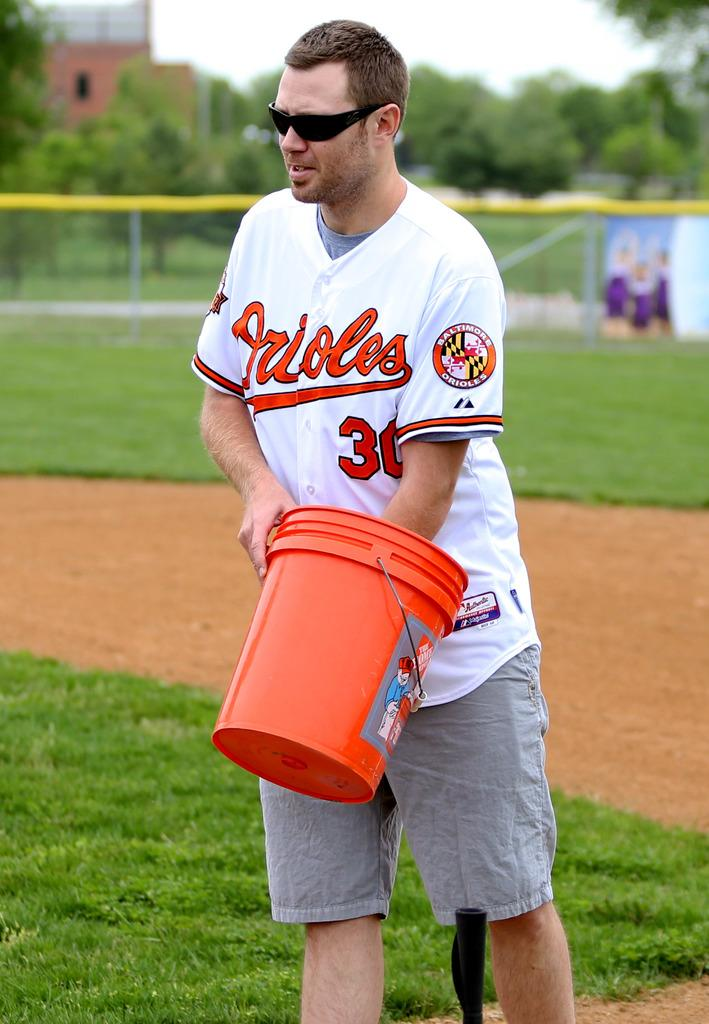Provide a one-sentence caption for the provided image. A man wearing sunglasses and an orioles jersey stands on a baseball field with his hand in a bucket. 